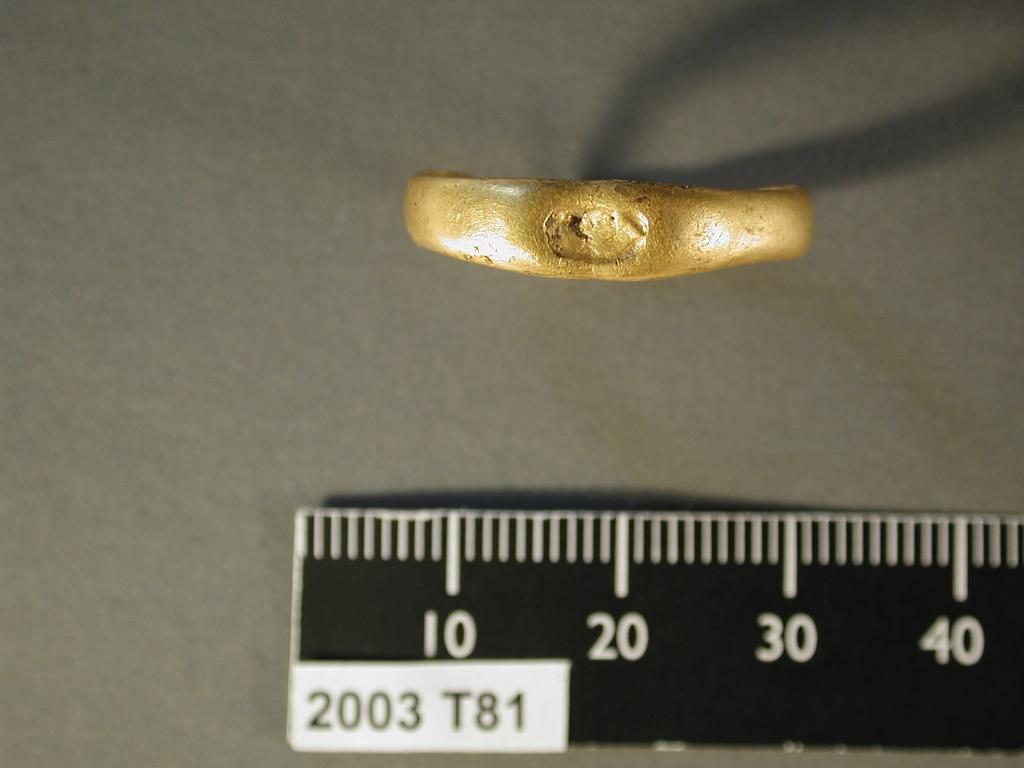Provide a one-sentence caption for the provided image. a small gold item placed near a ruler with numbers 10 20 30 and 40 shown. 